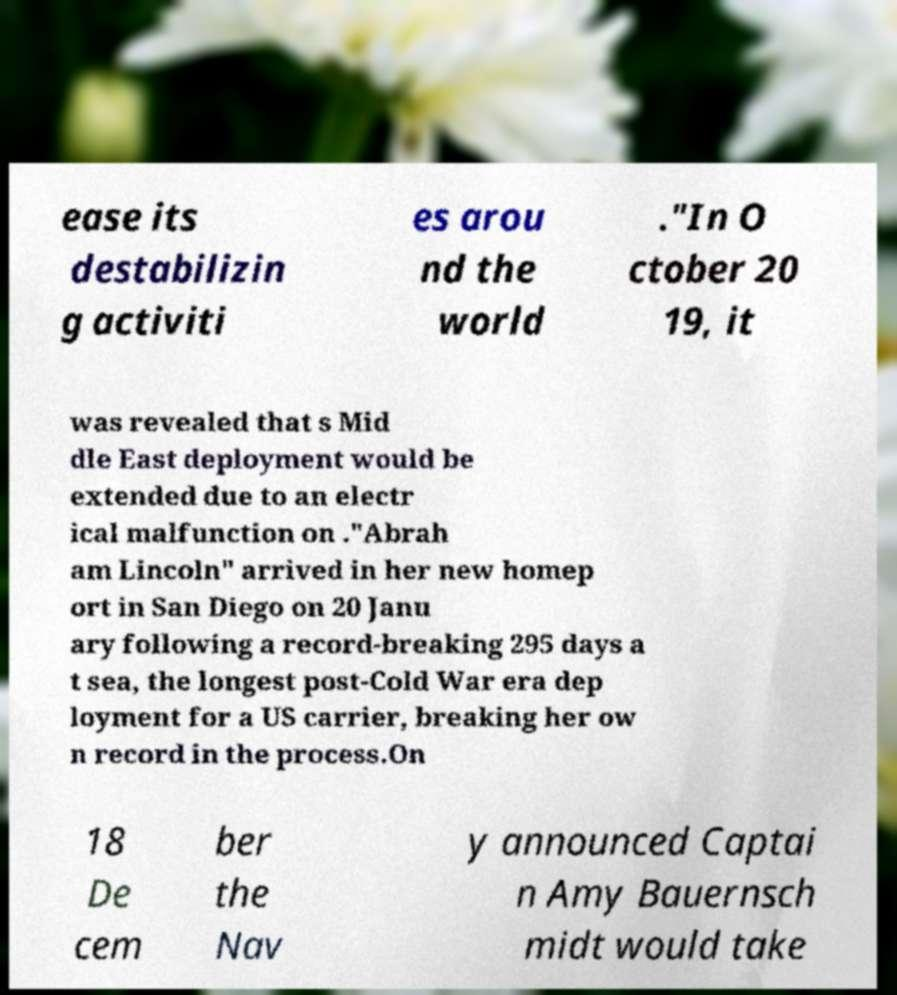Could you extract and type out the text from this image? ease its destabilizin g activiti es arou nd the world ."In O ctober 20 19, it was revealed that s Mid dle East deployment would be extended due to an electr ical malfunction on ."Abrah am Lincoln" arrived in her new homep ort in San Diego on 20 Janu ary following a record-breaking 295 days a t sea, the longest post-Cold War era dep loyment for a US carrier, breaking her ow n record in the process.On 18 De cem ber the Nav y announced Captai n Amy Bauernsch midt would take 